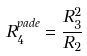<formula> <loc_0><loc_0><loc_500><loc_500>R ^ { p a d e } _ { 4 } = \frac { R _ { 3 } ^ { 2 } } { R _ { 2 } }</formula> 